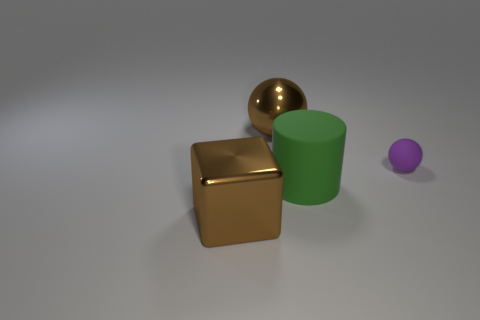Add 2 large brown things. How many objects exist? 6 Subtract all cylinders. How many objects are left? 3 Subtract all big green matte cylinders. Subtract all tiny matte balls. How many objects are left? 2 Add 1 brown balls. How many brown balls are left? 2 Add 4 cubes. How many cubes exist? 5 Subtract 0 blue spheres. How many objects are left? 4 